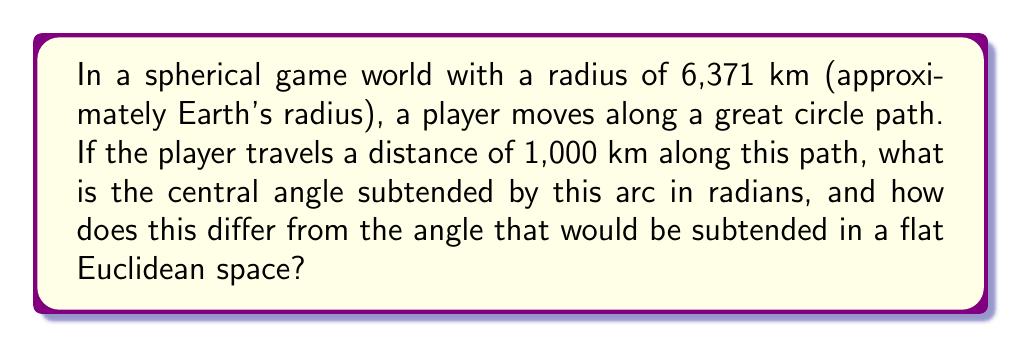Teach me how to tackle this problem. To solve this problem, we'll follow these steps:

1) In a spherical world, the central angle $\theta$ (in radians) subtended by an arc is given by the formula:

   $$\theta = \frac{s}{R}$$

   where $s$ is the arc length and $R$ is the radius of the sphere.

2) We're given:
   $s = 1,000$ km
   $R = 6,371$ km

3) Substituting these values:

   $$\theta = \frac{1,000}{6,371} \approx 0.1569 \text{ radians}$$

4) In a flat Euclidean space, the angle would be calculated as:

   $$\theta_{\text{flat}} = \frac{s}{R} = \frac{1,000}{6,371} \approx 0.1569 \text{ radians}$$

5) The difference between the spherical and flat space angles is:

   $$\Delta\theta = \theta - \theta_{\text{flat}} = 0.1569 - 0.1569 = 0$$

6) While the calculation appears the same, the interpretation and effect on gameplay are different:
   - In the spherical world, this angle represents actual curvature.
   - In a flat world, this would just be a proportion of the total circumference.

7) The curvature affects player movement by:
   - Changing the visual horizon
   - Altering the shortest path between two points (geodesics)
   - Affecting the sense of scale and distance

[asy]
import geometry;

unitsize(1cm);

pair O = (0,0);
real R = 5;
path c = circle(O, R);

real theta = 0.1569;
pair A = (R,0);
pair B = (R*cos(theta), R*sin(theta));

draw(c);
draw(O--A);
draw(O--B);
draw(arc(O, A, B), blue);

label("O", O, SW);
label("A", A, E);
label("B", B, NE);
label("R", (R/2,0), S);
label("$\theta$", (1,0.5));
label("s", (4.8,0.4), NW);

[/asy]
Answer: $\theta \approx 0.1569$ radians; no difference in calculation, but affects gameplay through curvature. 